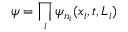<formula> <loc_0><loc_0><loc_500><loc_500>\psi = \prod _ { i } \psi _ { n _ { i } } ( x _ { i } , t , L _ { i } )</formula> 